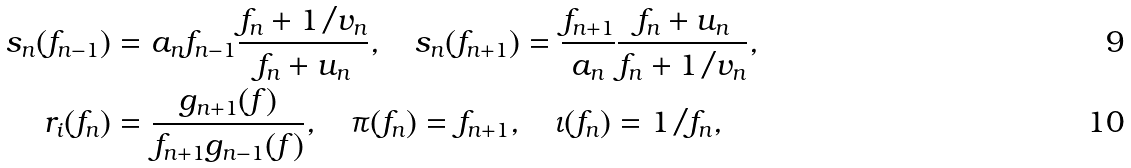Convert formula to latex. <formula><loc_0><loc_0><loc_500><loc_500>s _ { n } ( f _ { n - 1 } ) & = a _ { n } f _ { n - 1 } \frac { f _ { n } + 1 / { v _ { n } } } { f _ { n } + u _ { n } } , \quad s _ { n } ( f _ { n + 1 } ) = \frac { f _ { n + 1 } } { a _ { n } } \frac { f _ { n } + u _ { n } } { f _ { n } + 1 / { v _ { n } } } , \\ r _ { i } ( f _ { n } ) & = \frac { g _ { n + 1 } ( f ) } { f _ { n + 1 } g _ { n - 1 } ( f ) } , \quad \pi ( f _ { n } ) = f _ { n + 1 } , \quad \iota ( f _ { n } ) = { 1 } / { f _ { n } } ,</formula> 